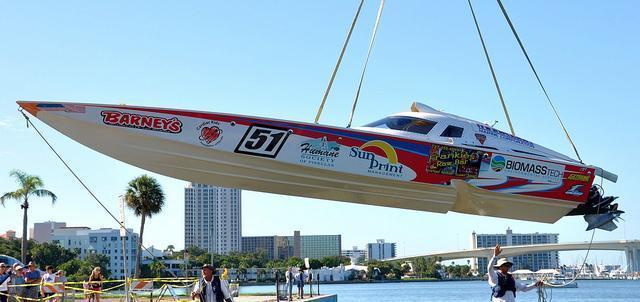How many bicycles are pictured here?
Give a very brief answer. 0. 